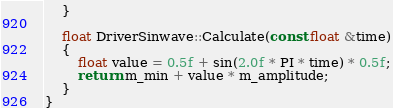<code> <loc_0><loc_0><loc_500><loc_500><_C++_>	}

	float DriverSinwave::Calculate(const float &time)
	{
		float value = 0.5f + sin(2.0f * PI * time) * 0.5f;
		return m_min + value * m_amplitude;
	}
}
</code> 